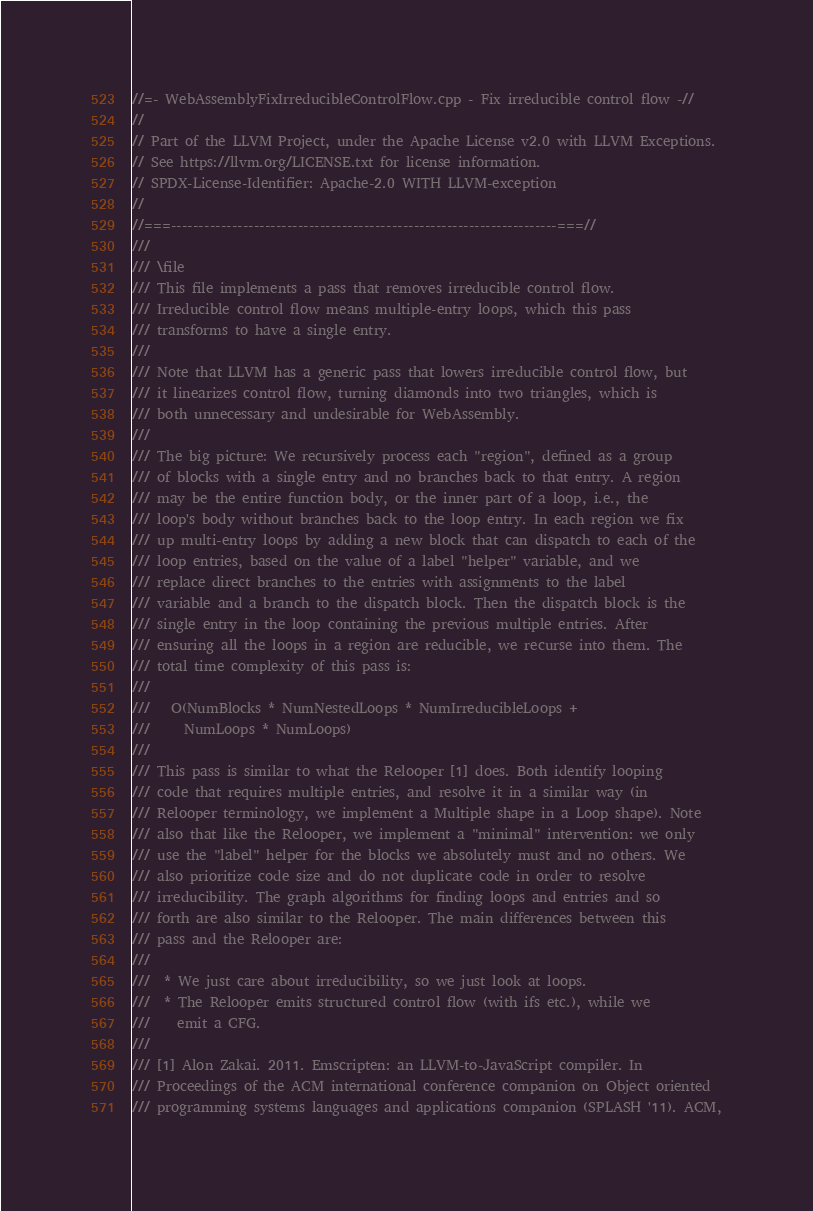<code> <loc_0><loc_0><loc_500><loc_500><_C++_>//=- WebAssemblyFixIrreducibleControlFlow.cpp - Fix irreducible control flow -//
//
// Part of the LLVM Project, under the Apache License v2.0 with LLVM Exceptions.
// See https://llvm.org/LICENSE.txt for license information.
// SPDX-License-Identifier: Apache-2.0 WITH LLVM-exception
//
//===----------------------------------------------------------------------===//
///
/// \file
/// This file implements a pass that removes irreducible control flow.
/// Irreducible control flow means multiple-entry loops, which this pass
/// transforms to have a single entry.
///
/// Note that LLVM has a generic pass that lowers irreducible control flow, but
/// it linearizes control flow, turning diamonds into two triangles, which is
/// both unnecessary and undesirable for WebAssembly.
///
/// The big picture: We recursively process each "region", defined as a group
/// of blocks with a single entry and no branches back to that entry. A region
/// may be the entire function body, or the inner part of a loop, i.e., the
/// loop's body without branches back to the loop entry. In each region we fix
/// up multi-entry loops by adding a new block that can dispatch to each of the
/// loop entries, based on the value of a label "helper" variable, and we
/// replace direct branches to the entries with assignments to the label
/// variable and a branch to the dispatch block. Then the dispatch block is the
/// single entry in the loop containing the previous multiple entries. After
/// ensuring all the loops in a region are reducible, we recurse into them. The
/// total time complexity of this pass is:
///
///   O(NumBlocks * NumNestedLoops * NumIrreducibleLoops +
///     NumLoops * NumLoops)
///
/// This pass is similar to what the Relooper [1] does. Both identify looping
/// code that requires multiple entries, and resolve it in a similar way (in
/// Relooper terminology, we implement a Multiple shape in a Loop shape). Note
/// also that like the Relooper, we implement a "minimal" intervention: we only
/// use the "label" helper for the blocks we absolutely must and no others. We
/// also prioritize code size and do not duplicate code in order to resolve
/// irreducibility. The graph algorithms for finding loops and entries and so
/// forth are also similar to the Relooper. The main differences between this
/// pass and the Relooper are:
///
///  * We just care about irreducibility, so we just look at loops.
///  * The Relooper emits structured control flow (with ifs etc.), while we
///    emit a CFG.
///
/// [1] Alon Zakai. 2011. Emscripten: an LLVM-to-JavaScript compiler. In
/// Proceedings of the ACM international conference companion on Object oriented
/// programming systems languages and applications companion (SPLASH '11). ACM,</code> 